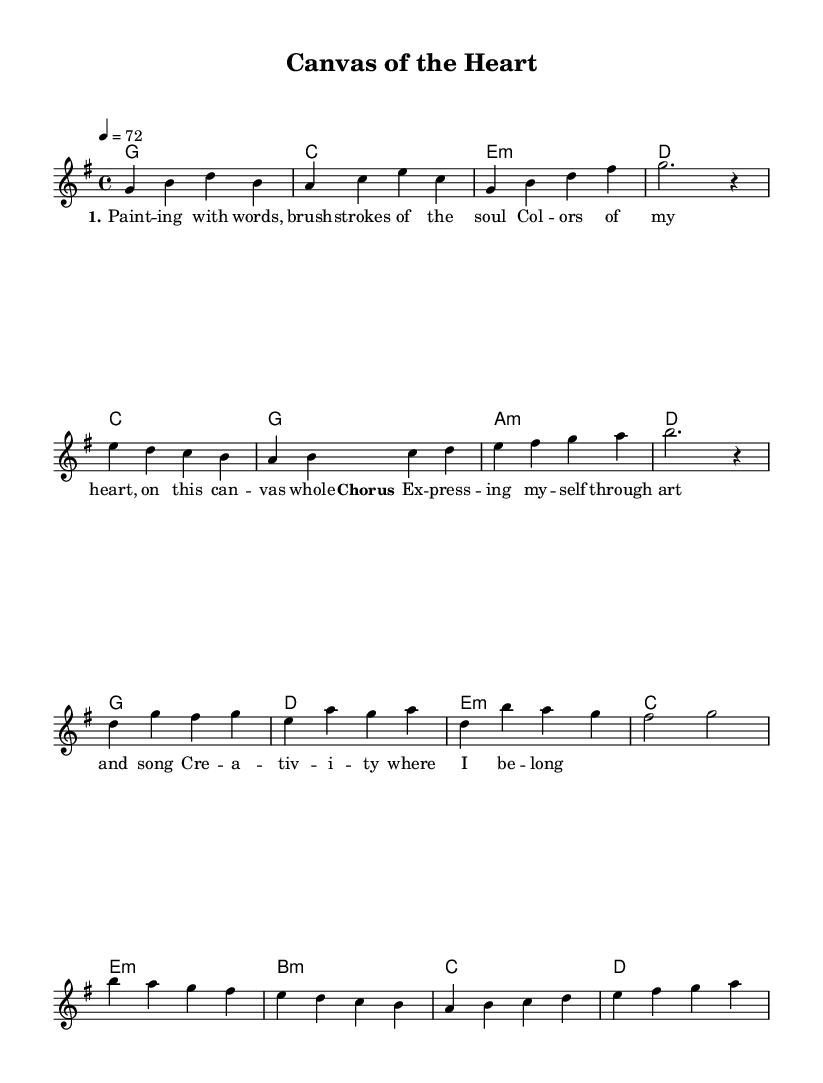What is the key signature of this music? The key signature is G major, which has one sharp (F#). This can be determined by looking at the key signature at the beginning of the sheet music.
Answer: G major What is the time signature of this composition? The time signature shown in the sheet music is 4/4, meaning there are four beats in each measure and the quarter note gets one beat. This is indicated right after the key signature at the start of the score.
Answer: 4/4 What is the tempo marking for this piece? The tempo marking indicates a speed of 72 beats per minute. This is found in the tempo indication section of the music, specifically the marking "4 = 72.”
Answer: 72 How many measures are in the chorus section? The chorus section contains four measures. By counting the measures notated within the lyrics and melody marked as 'Chorus,' we find that there are four distinct measures present.
Answer: 4 What can be inferred about the style of this piece based on its lyrics? The lyrics emphasize artistic expression and creativity, often exploring themes of self-expression through art, which is characteristic of K-Pop ballads that show emotional depth and personal reflection. These themes are illuminated within the lyrics section provided and the title "Canvas of the Heart."
Answer: Artistic expression What is the overall structure of the piece? The overall structure is Verse, Pre-Chorus, Chorus, and Bridge. This can be deduced by looking at the arrangement of the music and lyrics sections which label each part sequentially.
Answer: Verse, Pre-Chorus, Chorus, Bridge 